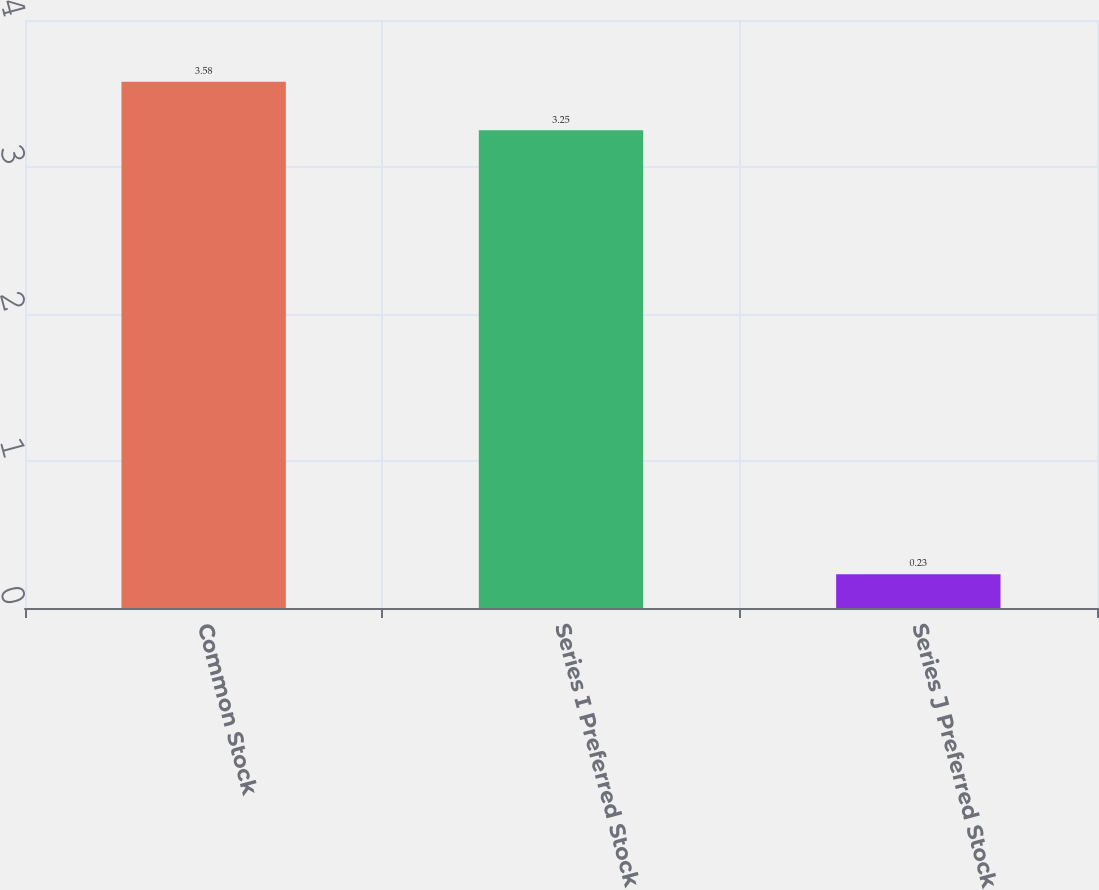Convert chart. <chart><loc_0><loc_0><loc_500><loc_500><bar_chart><fcel>Common Stock<fcel>Series I Preferred Stock<fcel>Series J Preferred Stock<nl><fcel>3.58<fcel>3.25<fcel>0.23<nl></chart> 